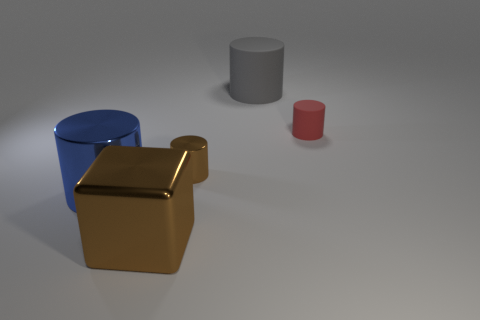The big thing to the right of the big brown metal object in front of the tiny shiny cylinder is made of what material?
Provide a succinct answer. Rubber. Are any large shiny things visible?
Your answer should be very brief. Yes. What size is the brown thing behind the cylinder that is in front of the tiny metal object?
Your response must be concise. Small. Is the number of objects that are to the left of the big metal cylinder greater than the number of brown blocks behind the small red rubber object?
Keep it short and to the point. No. What number of cylinders are big rubber objects or big brown metal objects?
Your response must be concise. 1. There is a large metallic object that is in front of the large metallic cylinder; is it the same shape as the blue thing?
Your answer should be very brief. No. The big rubber cylinder is what color?
Offer a very short reply. Gray. What is the color of the large matte object that is the same shape as the small rubber thing?
Your answer should be compact. Gray. How many small brown things have the same shape as the gray object?
Ensure brevity in your answer.  1. What number of objects are either small purple cylinders or big metal things to the right of the blue metal object?
Make the answer very short. 1. 